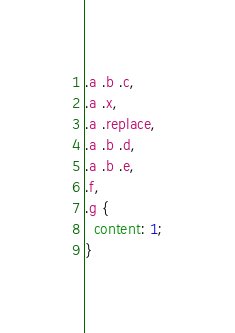<code> <loc_0><loc_0><loc_500><loc_500><_CSS_>.a .b .c,
.a .x,
.a .replace,
.a .b .d,
.a .b .e,
.f,
.g {
  content: 1;
}
</code> 